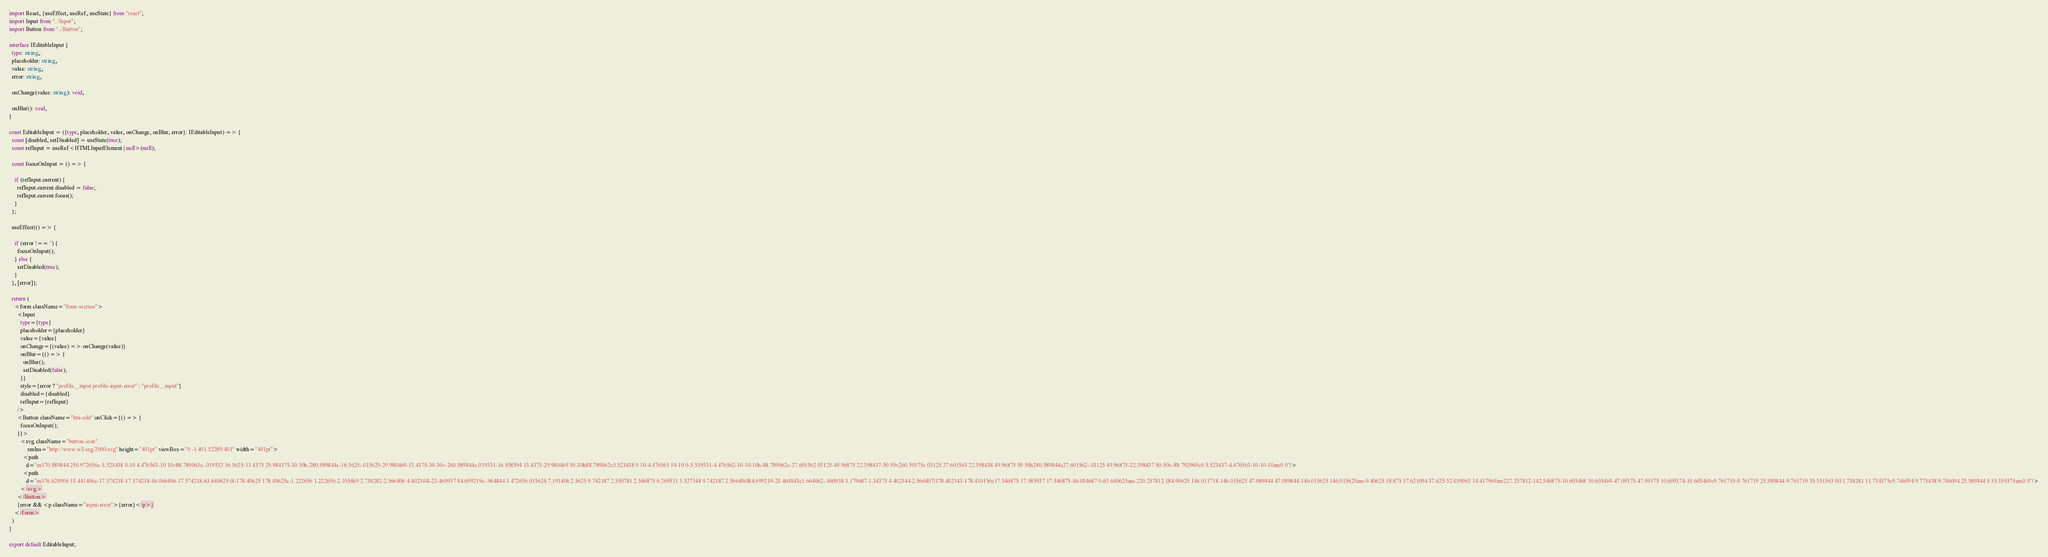<code> <loc_0><loc_0><loc_500><loc_500><_TypeScript_>import React, {useEffect, useRef, useState} from "react";
import Input from "../Input";
import Button from "../Button";

interface IEditableInput {
  type: string,
  placeholder: string,
  value: string,
  error: string,

  onChange(value: string): void,

  onBlur(): void,
}

const EditableInput = ({type, placeholder, value, onChange, onBlur, error}: IEditableInput) => {
  const [disabled, setDisabled] = useState(true);
  const refInput = useRef<HTMLInputElement | null>(null);

  const focusOnInput = () => {

    if (refInput.current) {
      refInput.current.disabled = false;
      refInput.current.focus();
    }
  };

  useEffect(() => {

    if (error !== '') {
      focusOnInput();
    } else {
      setDisabled(true);
    }
  }, [error]);

  return (
    <form className="form-section">
      <Input
        type={type}
        placeholder={placeholder}
        value={value}
        onChange={(value) => onChange(value)}
        onBlur={() => {
          onBlur();
          setDisabled(false);
        }}
        style={error ? "profile__input profile-input-error" : "profile__input"}
        disabled={disabled}
        refInput={refInput}
      />
      <Button className="btn-edit" onClick={() => {
        focusOnInput();
      }}>
        <svg className="button-icon"
             xmlns="http://www.w3.org/2000/svg" height="401pt" viewBox="0 -1 401.52289 401" width="401pt">
          <path
            d="m370.589844 250.972656c-5.523438 0-10 4.476563-10 10v88.789063c-.019532 16.5625-13.4375 29.984375-30 30h-280.589844c-16.5625-.015625-29.980469-13.4375-30-30v-260.589844c.019531-16.558594 13.4375-29.980469 30-30h88.789062c5.523438 0 10-4.476563 10-10 0-5.519531-4.476562-10-10-10h-88.789062c-27.601562.03125-49.96875 22.398437-50 50v260.59375c.03125 27.601563 22.398438 49.96875 50 50h280.589844c27.601562-.03125 49.96875-22.398437 50-50v-88.792969c0-5.523437-4.476563-10-10-10zm0 0"/>
          <path
            d="m376.628906 13.441406c-17.574218-17.574218-46.066406-17.574218-63.640625 0l-178.40625 178.40625c-1.222656 1.222656-2.105469 2.738282-2.566406 4.402344l-23.460937 84.699219c-.964844 3.472656.015624 7.191406 2.5625 9.742187 2.550781 2.546875 6.269531 3.527344 9.742187 2.566406l84.699219-23.464843c1.664062-.460938 3.179687-1.34375 4.402344-2.566407l178.402343-178.410156c17.546875-17.585937 17.546875-46.054687 0-63.640625zm-220.257812 184.90625 146.011718-146.015625 47.089844 47.089844-146.015625 146.015625zm-9.40625 18.875 37.621094 37.625-52.039063 14.417969zm227.257812-142.546875-10.605468 10.605469-47.09375-47.09375 10.609374-10.605469c9.761719-9.761719 25.589844-9.761719 35.351563 0l11.738281 11.734375c9.746094 9.773438 9.746094 25.589844 0 35.359375zm0 0"/>
        </svg>
      </Button>
      {error && <p className="input-error">{error}</p>}
    </form>
  )
}

export default EditableInput;
</code> 